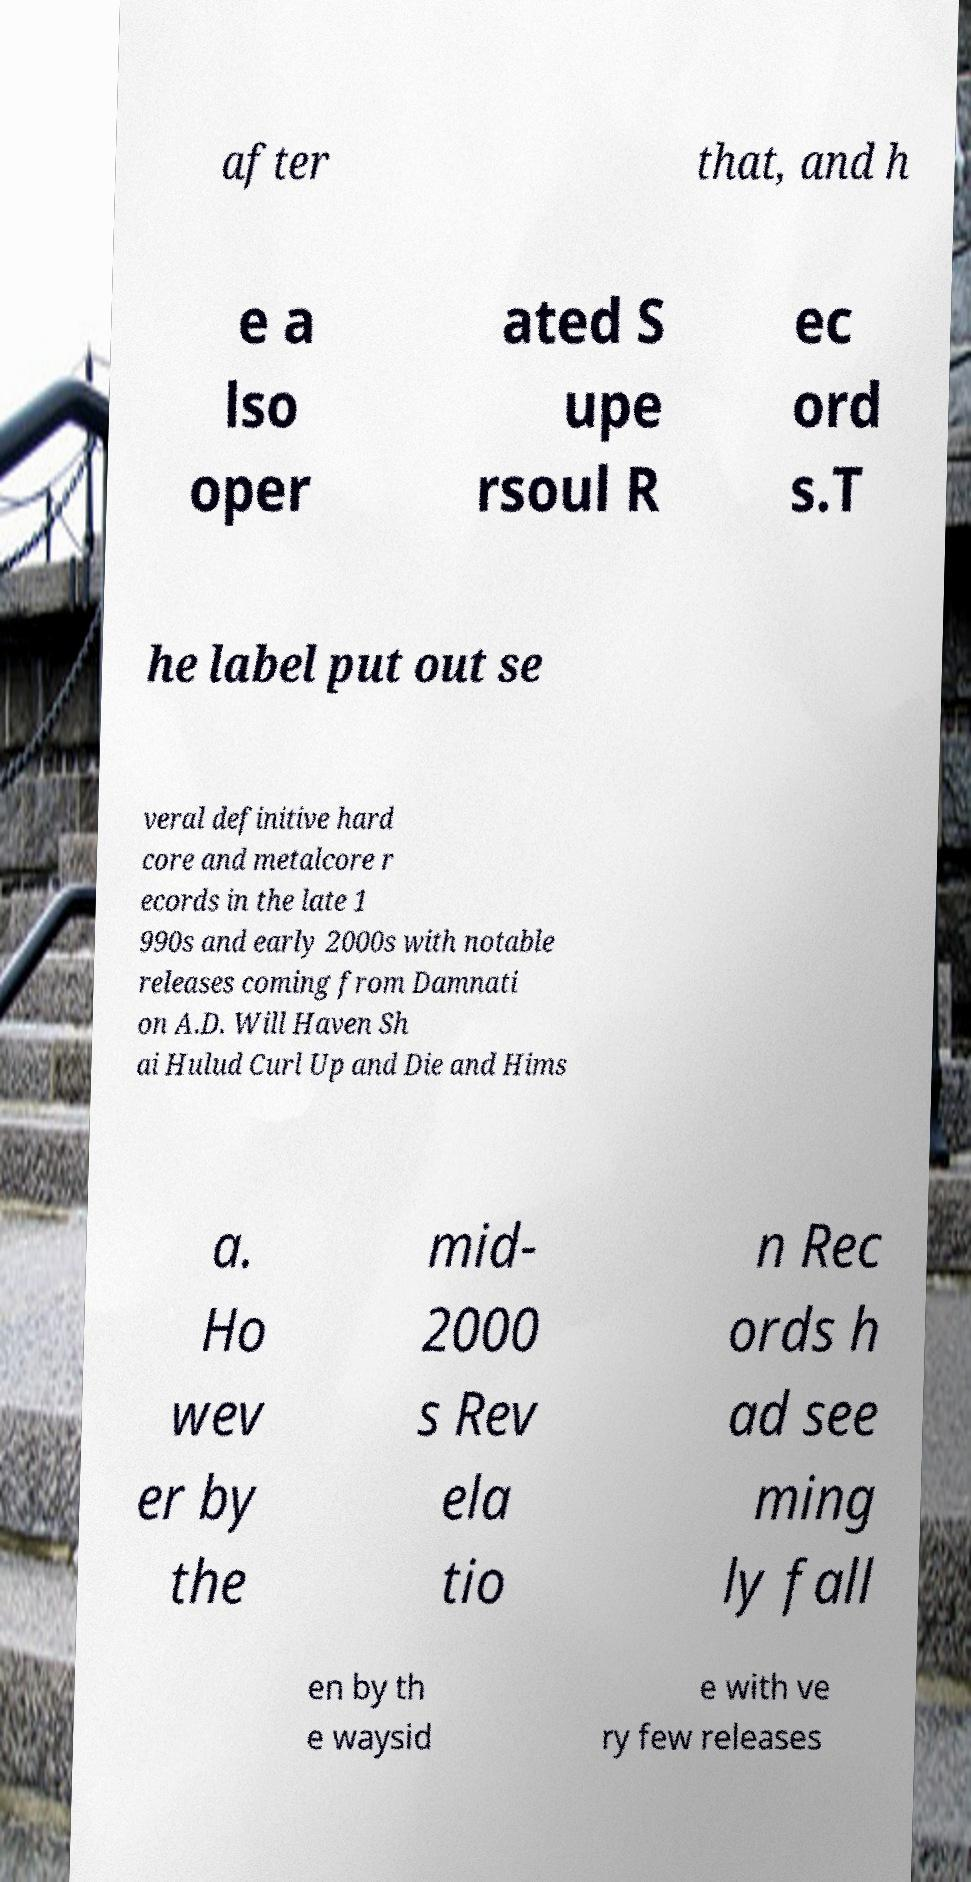Please read and relay the text visible in this image. What does it say? after that, and h e a lso oper ated S upe rsoul R ec ord s.T he label put out se veral definitive hard core and metalcore r ecords in the late 1 990s and early 2000s with notable releases coming from Damnati on A.D. Will Haven Sh ai Hulud Curl Up and Die and Hims a. Ho wev er by the mid- 2000 s Rev ela tio n Rec ords h ad see ming ly fall en by th e waysid e with ve ry few releases 